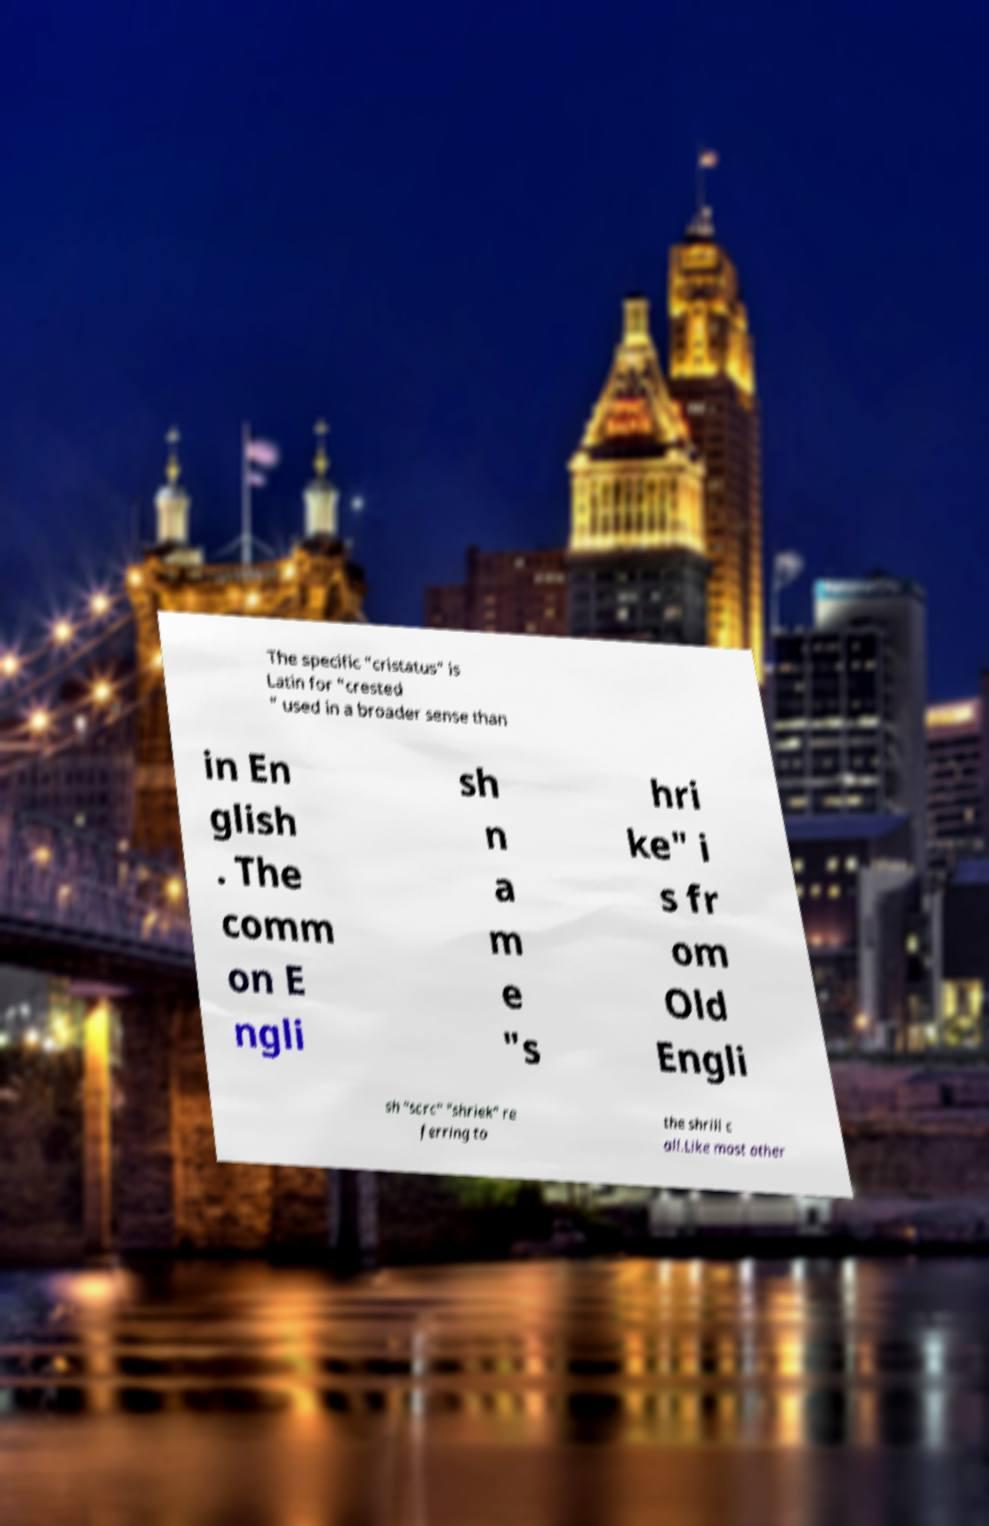For documentation purposes, I need the text within this image transcribed. Could you provide that? The specific "cristatus" is Latin for "crested " used in a broader sense than in En glish . The comm on E ngli sh n a m e "s hri ke" i s fr om Old Engli sh "scrc" "shriek" re ferring to the shrill c all.Like most other 